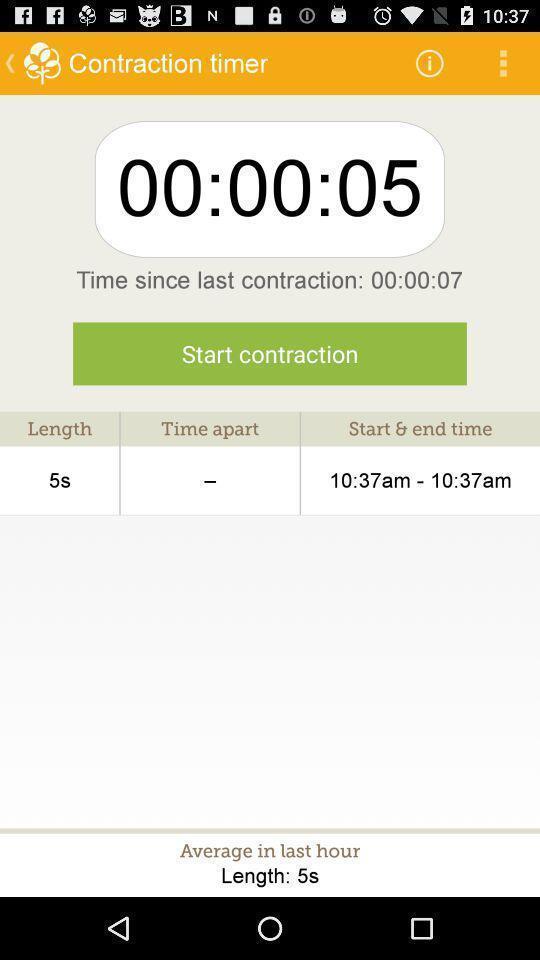Give me a narrative description of this picture. Time duration in the contraction timer. 